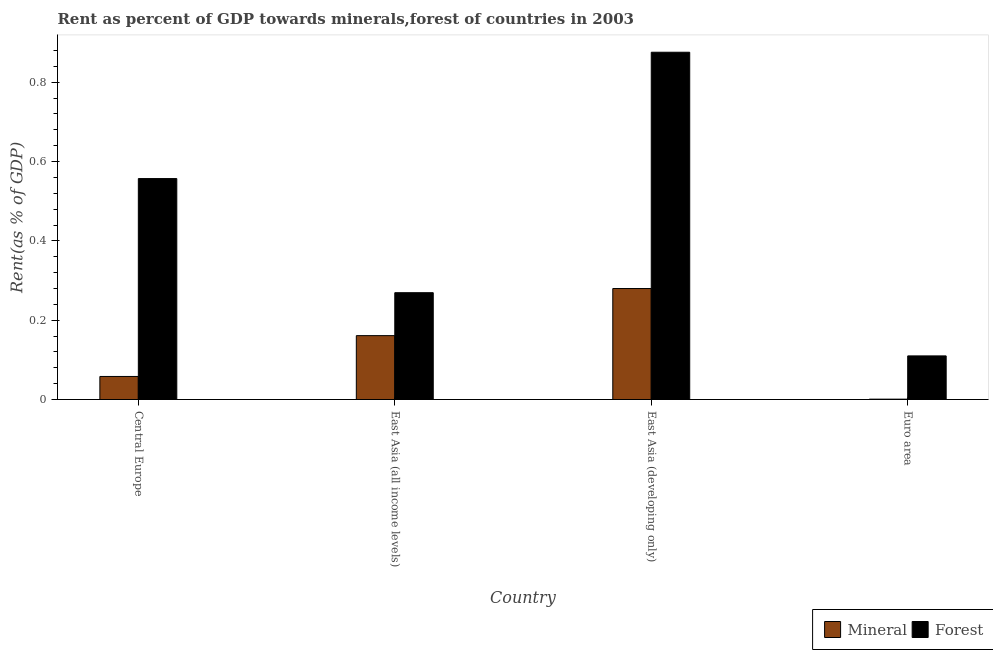How many bars are there on the 1st tick from the left?
Offer a very short reply. 2. How many bars are there on the 2nd tick from the right?
Offer a very short reply. 2. What is the label of the 1st group of bars from the left?
Your answer should be very brief. Central Europe. What is the mineral rent in Euro area?
Provide a short and direct response. 0. Across all countries, what is the maximum mineral rent?
Give a very brief answer. 0.28. Across all countries, what is the minimum mineral rent?
Provide a succinct answer. 0. In which country was the forest rent maximum?
Offer a very short reply. East Asia (developing only). In which country was the mineral rent minimum?
Your answer should be very brief. Euro area. What is the total forest rent in the graph?
Offer a very short reply. 1.81. What is the difference between the forest rent in East Asia (developing only) and that in Euro area?
Make the answer very short. 0.77. What is the difference between the forest rent in East Asia (developing only) and the mineral rent in East Asia (all income levels)?
Provide a short and direct response. 0.71. What is the average mineral rent per country?
Ensure brevity in your answer.  0.12. What is the difference between the forest rent and mineral rent in Euro area?
Ensure brevity in your answer.  0.11. In how many countries, is the mineral rent greater than 0.12 %?
Provide a short and direct response. 2. What is the ratio of the forest rent in Central Europe to that in East Asia (all income levels)?
Give a very brief answer. 2.07. Is the difference between the mineral rent in Central Europe and East Asia (developing only) greater than the difference between the forest rent in Central Europe and East Asia (developing only)?
Offer a very short reply. Yes. What is the difference between the highest and the second highest mineral rent?
Offer a terse response. 0.12. What is the difference between the highest and the lowest mineral rent?
Provide a short and direct response. 0.28. Is the sum of the mineral rent in East Asia (developing only) and Euro area greater than the maximum forest rent across all countries?
Your response must be concise. No. What does the 1st bar from the left in Central Europe represents?
Ensure brevity in your answer.  Mineral. What does the 2nd bar from the right in East Asia (all income levels) represents?
Provide a succinct answer. Mineral. What is the difference between two consecutive major ticks on the Y-axis?
Make the answer very short. 0.2. Does the graph contain any zero values?
Provide a short and direct response. No. Where does the legend appear in the graph?
Offer a terse response. Bottom right. How are the legend labels stacked?
Your response must be concise. Horizontal. What is the title of the graph?
Your response must be concise. Rent as percent of GDP towards minerals,forest of countries in 2003. What is the label or title of the X-axis?
Your answer should be very brief. Country. What is the label or title of the Y-axis?
Offer a very short reply. Rent(as % of GDP). What is the Rent(as % of GDP) of Mineral in Central Europe?
Ensure brevity in your answer.  0.06. What is the Rent(as % of GDP) in Forest in Central Europe?
Ensure brevity in your answer.  0.56. What is the Rent(as % of GDP) of Mineral in East Asia (all income levels)?
Give a very brief answer. 0.16. What is the Rent(as % of GDP) of Forest in East Asia (all income levels)?
Your answer should be very brief. 0.27. What is the Rent(as % of GDP) of Mineral in East Asia (developing only)?
Give a very brief answer. 0.28. What is the Rent(as % of GDP) in Forest in East Asia (developing only)?
Offer a terse response. 0.88. What is the Rent(as % of GDP) of Mineral in Euro area?
Offer a terse response. 0. What is the Rent(as % of GDP) of Forest in Euro area?
Your answer should be very brief. 0.11. Across all countries, what is the maximum Rent(as % of GDP) of Mineral?
Offer a terse response. 0.28. Across all countries, what is the maximum Rent(as % of GDP) in Forest?
Keep it short and to the point. 0.88. Across all countries, what is the minimum Rent(as % of GDP) in Mineral?
Your answer should be compact. 0. Across all countries, what is the minimum Rent(as % of GDP) of Forest?
Provide a succinct answer. 0.11. What is the total Rent(as % of GDP) in Forest in the graph?
Give a very brief answer. 1.81. What is the difference between the Rent(as % of GDP) in Mineral in Central Europe and that in East Asia (all income levels)?
Provide a short and direct response. -0.1. What is the difference between the Rent(as % of GDP) in Forest in Central Europe and that in East Asia (all income levels)?
Give a very brief answer. 0.29. What is the difference between the Rent(as % of GDP) of Mineral in Central Europe and that in East Asia (developing only)?
Your response must be concise. -0.22. What is the difference between the Rent(as % of GDP) of Forest in Central Europe and that in East Asia (developing only)?
Offer a very short reply. -0.32. What is the difference between the Rent(as % of GDP) of Mineral in Central Europe and that in Euro area?
Ensure brevity in your answer.  0.06. What is the difference between the Rent(as % of GDP) of Forest in Central Europe and that in Euro area?
Your response must be concise. 0.45. What is the difference between the Rent(as % of GDP) in Mineral in East Asia (all income levels) and that in East Asia (developing only)?
Provide a short and direct response. -0.12. What is the difference between the Rent(as % of GDP) of Forest in East Asia (all income levels) and that in East Asia (developing only)?
Ensure brevity in your answer.  -0.61. What is the difference between the Rent(as % of GDP) in Mineral in East Asia (all income levels) and that in Euro area?
Provide a short and direct response. 0.16. What is the difference between the Rent(as % of GDP) in Forest in East Asia (all income levels) and that in Euro area?
Give a very brief answer. 0.16. What is the difference between the Rent(as % of GDP) of Mineral in East Asia (developing only) and that in Euro area?
Offer a terse response. 0.28. What is the difference between the Rent(as % of GDP) of Forest in East Asia (developing only) and that in Euro area?
Offer a terse response. 0.77. What is the difference between the Rent(as % of GDP) in Mineral in Central Europe and the Rent(as % of GDP) in Forest in East Asia (all income levels)?
Ensure brevity in your answer.  -0.21. What is the difference between the Rent(as % of GDP) of Mineral in Central Europe and the Rent(as % of GDP) of Forest in East Asia (developing only)?
Provide a succinct answer. -0.82. What is the difference between the Rent(as % of GDP) in Mineral in Central Europe and the Rent(as % of GDP) in Forest in Euro area?
Your answer should be compact. -0.05. What is the difference between the Rent(as % of GDP) of Mineral in East Asia (all income levels) and the Rent(as % of GDP) of Forest in East Asia (developing only)?
Keep it short and to the point. -0.71. What is the difference between the Rent(as % of GDP) of Mineral in East Asia (all income levels) and the Rent(as % of GDP) of Forest in Euro area?
Give a very brief answer. 0.05. What is the difference between the Rent(as % of GDP) of Mineral in East Asia (developing only) and the Rent(as % of GDP) of Forest in Euro area?
Your response must be concise. 0.17. What is the average Rent(as % of GDP) of Forest per country?
Your answer should be very brief. 0.45. What is the difference between the Rent(as % of GDP) in Mineral and Rent(as % of GDP) in Forest in Central Europe?
Offer a terse response. -0.5. What is the difference between the Rent(as % of GDP) in Mineral and Rent(as % of GDP) in Forest in East Asia (all income levels)?
Your answer should be compact. -0.11. What is the difference between the Rent(as % of GDP) of Mineral and Rent(as % of GDP) of Forest in East Asia (developing only)?
Keep it short and to the point. -0.6. What is the difference between the Rent(as % of GDP) in Mineral and Rent(as % of GDP) in Forest in Euro area?
Offer a terse response. -0.11. What is the ratio of the Rent(as % of GDP) of Mineral in Central Europe to that in East Asia (all income levels)?
Your answer should be very brief. 0.36. What is the ratio of the Rent(as % of GDP) of Forest in Central Europe to that in East Asia (all income levels)?
Give a very brief answer. 2.07. What is the ratio of the Rent(as % of GDP) in Mineral in Central Europe to that in East Asia (developing only)?
Offer a very short reply. 0.21. What is the ratio of the Rent(as % of GDP) of Forest in Central Europe to that in East Asia (developing only)?
Ensure brevity in your answer.  0.64. What is the ratio of the Rent(as % of GDP) of Mineral in Central Europe to that in Euro area?
Provide a short and direct response. 63.39. What is the ratio of the Rent(as % of GDP) of Forest in Central Europe to that in Euro area?
Your response must be concise. 5.07. What is the ratio of the Rent(as % of GDP) in Mineral in East Asia (all income levels) to that in East Asia (developing only)?
Make the answer very short. 0.58. What is the ratio of the Rent(as % of GDP) of Forest in East Asia (all income levels) to that in East Asia (developing only)?
Give a very brief answer. 0.31. What is the ratio of the Rent(as % of GDP) of Mineral in East Asia (all income levels) to that in Euro area?
Provide a short and direct response. 175.67. What is the ratio of the Rent(as % of GDP) in Forest in East Asia (all income levels) to that in Euro area?
Your response must be concise. 2.45. What is the ratio of the Rent(as % of GDP) in Mineral in East Asia (developing only) to that in Euro area?
Provide a succinct answer. 305.22. What is the ratio of the Rent(as % of GDP) in Forest in East Asia (developing only) to that in Euro area?
Give a very brief answer. 7.96. What is the difference between the highest and the second highest Rent(as % of GDP) of Mineral?
Make the answer very short. 0.12. What is the difference between the highest and the second highest Rent(as % of GDP) in Forest?
Ensure brevity in your answer.  0.32. What is the difference between the highest and the lowest Rent(as % of GDP) of Mineral?
Make the answer very short. 0.28. What is the difference between the highest and the lowest Rent(as % of GDP) in Forest?
Offer a very short reply. 0.77. 